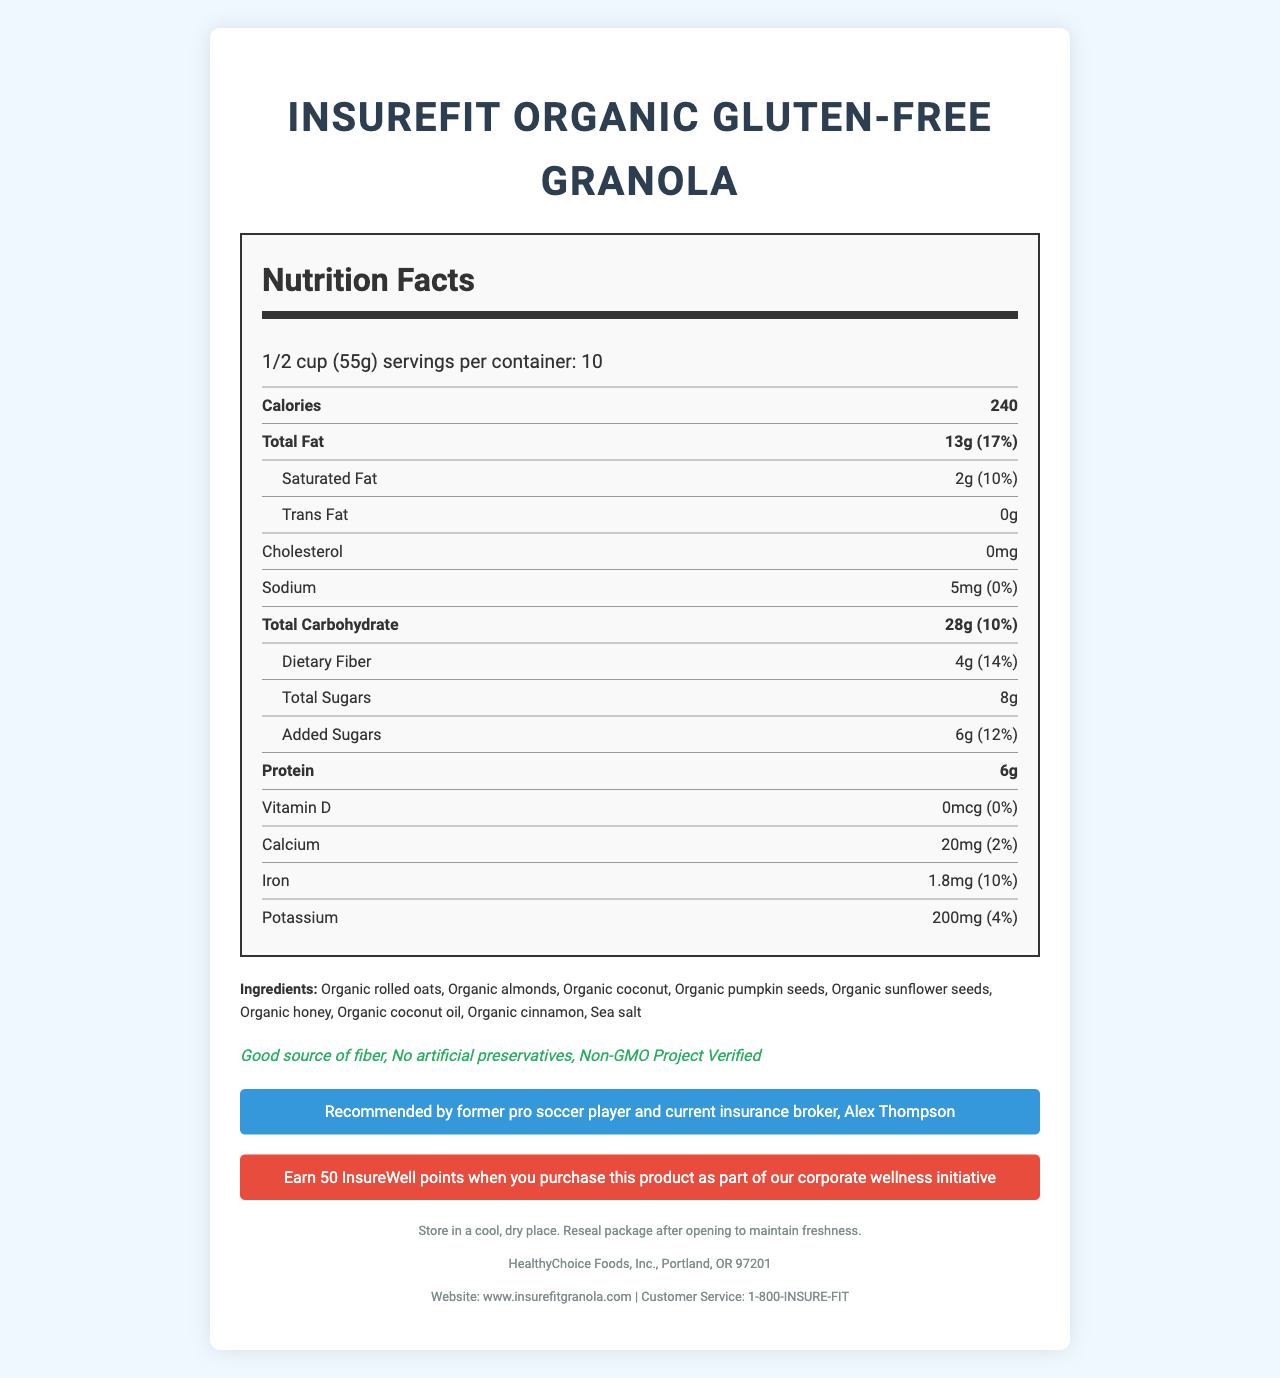what is the serving size? The serving size is given in the "Nutrition Facts" section, specified as "1/2 cup (55g)".
Answer: 1/2 cup (55g) how many servings are in one container? The number of servings per container is listed as "10" in the "Nutrition Facts" section.
Answer: 10 how many calories are there per serving? The calorie count per serving is specified as "240" in the "Nutrition Facts" section.
Answer: 240 what is the total fat content per serving? The total fat content per serving is listed as "13g" in the "Nutrition Facts" section.
Answer: 13g how much protein does one serving contain? The amount of protein per serving is provided as "6g" in the "Nutrition Facts" section.
Answer: 6g how much added sugars are in one serving? The amount of added sugars per serving is specified as "6g" in the "Nutrition Facts" section.
Answer: 6g list all the ingredients contained in this granola. The ingredients are listed beneath the "Ingredients" section in the document.
Answer: Organic rolled oats, Organic almonds, Organic coconut, Organic pumpkin seeds, Organic sunflower seeds, Organic honey, Organic coconut oil, Organic cinnamon, Sea salt how much dietary fiber is in each serving, and what percentage of the daily value does it represent? Each serving contains 4g of dietary fiber, which represents 14% of the daily value.
Answer: 4g, 14% who endorses this granola and what is their current role? The endorsement is by "former pro soccer player and current insurance broker, Alex Thompson" in the "athlete endorsement" section.
Answer: Alex Thompson, former pro soccer player and current insurance broker what are the benefits of this granola according to the health claims listed on the label? The health claims section lists these benefits.
Answer: Good source of fiber, No artificial preservatives, Non-GMO Project Verified does this product contain any artificial preservatives? The health claim "No artificial preservatives" indicates that the product does not contain any artificial preservatives.
Answer: No choose the correct daily value percentages of Iron in one serving: A. 5% B. 10% C. 15% D. 20% The daily value percentage for Iron is listed as 10% in the "Nutrition Facts" section.
Answer: B. 10% which of the following ingredients are found in the granola? A. Organic rolled oats B. Organic pumpkin seeds C. Organic honey D. All of the above All these ingredients (Organic rolled oats, Organic pumpkin seeds, Organic honey) are listed under the "Ingredients" section.
Answer: D. All of the above describe the allergen information mentioned in the document. The allergen information section clearly states the presence of tree nuts and the facility's cross-processing details.
Answer: The granola contains tree nuts (almonds, coconut) and is produced in a facility that also processes peanuts and other tree nuts. is this granola a good source of Vitamin D? The "Nutrition Facts" section indicates that the granola contains 0mcg of Vitamin D, which is 0% of the daily value, meaning it is not a source of Vitamin D.
Answer: No can this granola be purchased as part of a corporate wellness initiative? If yes, what benefit does it offer? The "insurance wellness program" section mentions that purchasing this product offers 50 InsureWell points as part of a corporate wellness initiative.
Answer: Yes, it offers 50 InsureWell points. what is the website for more information about this granola? The website is provided in the footer section of the document.
Answer: www.insurefitgranola.com what is the calcium content per serving, and how many percent of the daily value does it fulfill? The calcium content per serving is 20mg, which fulfills 2% of the daily value according to the "Nutrition Facts" section.
Answer: 20mg, 2% is this granola gluten-free? The label does not specifically state that it is gluten-free, so we cannot determine this from the provided information.
Answer: Cannot be determined summarize the main idea of the document. The document provides comprehensive information about the granola product aiming to address the concerns of health-conscious consumers and professionals in the insurance industry.
Answer: The document details the nutritional information, ingredients, health claims, allergen information, endorsements, and wellness benefits of the InsureFit Organic Gluten-Free Granola. It provides information about serving size, calorie count, fat content, and other nutritional values. It also includes storage instructions, manufacturer details, and contact information for further inquiries. 